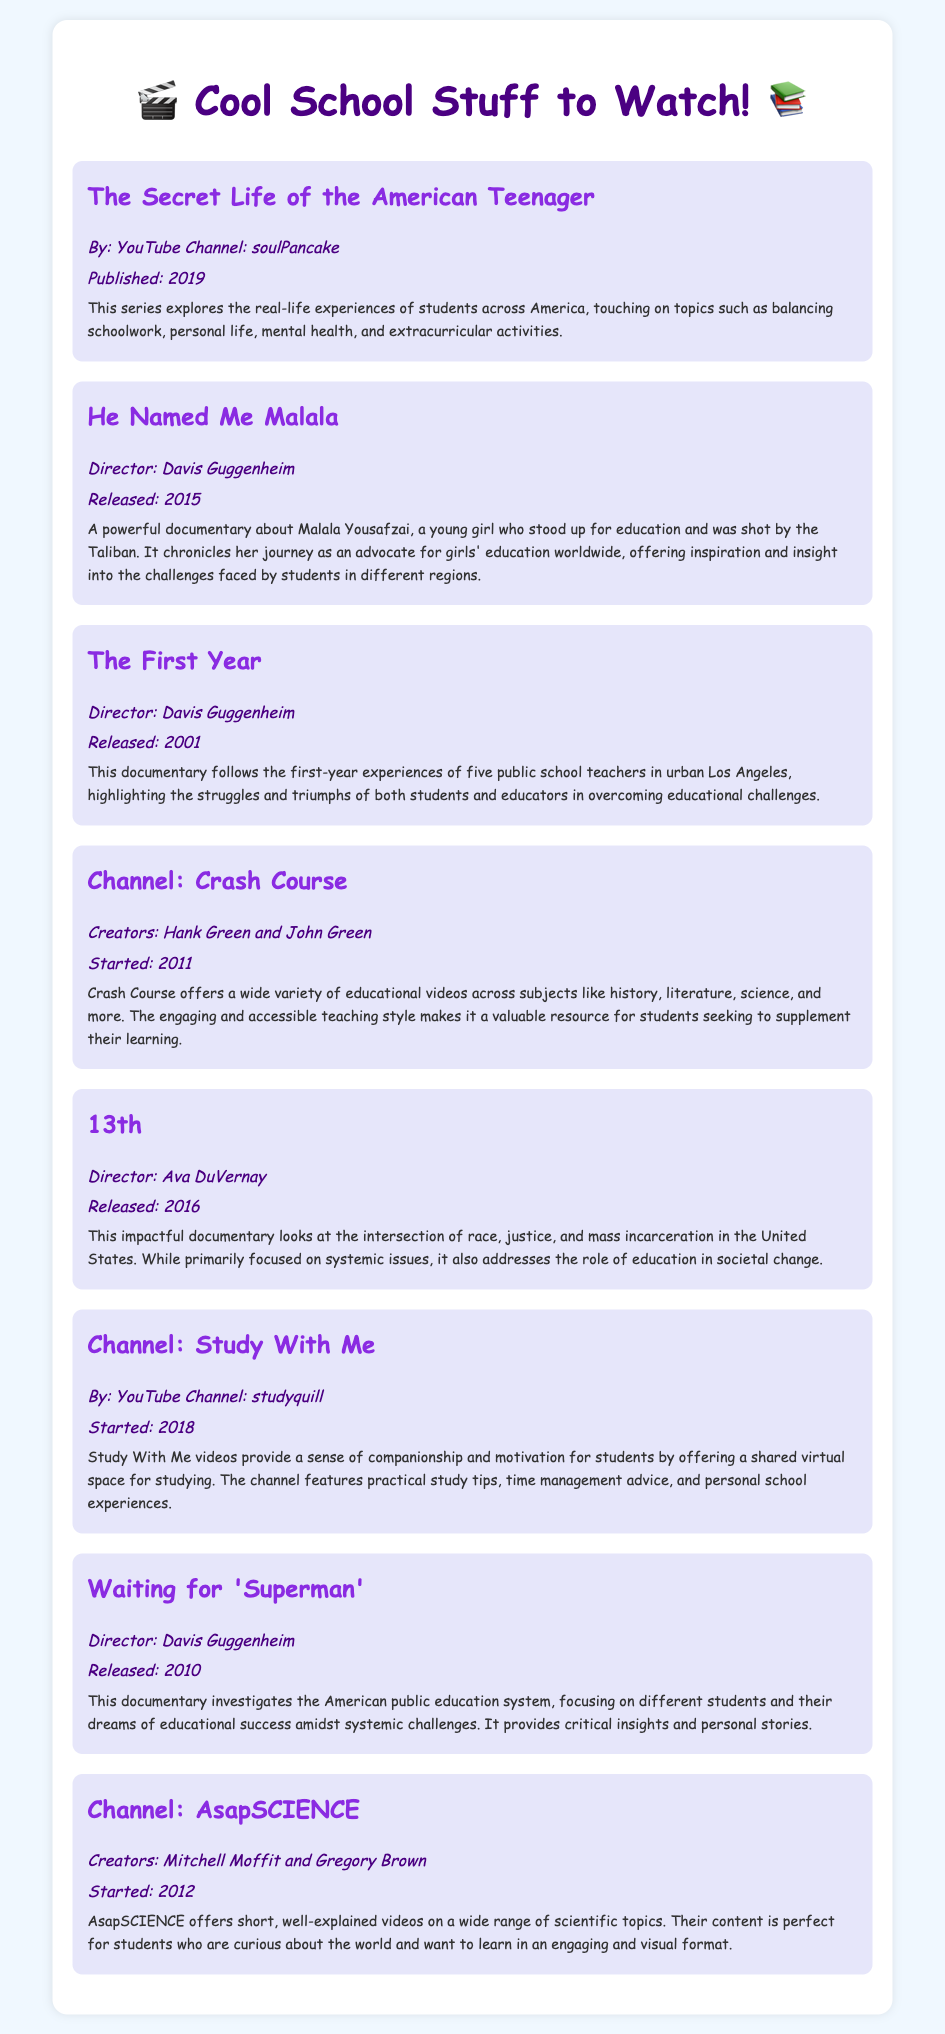What is the title of the series that explores real-life experiences of students across America? The title is mentioned at the top of the first entry, indicating a focus on student experiences.
Answer: The Secret Life of the American Teenager Who directed the documentary "He Named Me Malala"? The director's name is clearly stated in the description of the documentary.
Answer: Davis Guggenheim In what year was "The First Year" released? The release year is indicated in the date section of the entry.
Answer: 2001 What YouTube channel started in 2011 and offers a variety of educational videos? The creation date and purpose of the channel is detailed in the description.
Answer: Crash Course How many entries are there in the document? The total number of entries can be counted from the list provided in the document.
Answer: 8 What film discusses the intersection of race and education? The title is found in the entry focusing on systemic issues related to education.
Answer: 13th What is the main theme of the documentary "Waiting for 'Superman'"? The description provides insight into what the documentary explores regarding educational challenges.
Answer: American public education system Which channel helps students with study motivation? The channel's focus is described in its entry regarding study tips and companionship.
Answer: Study With Me 